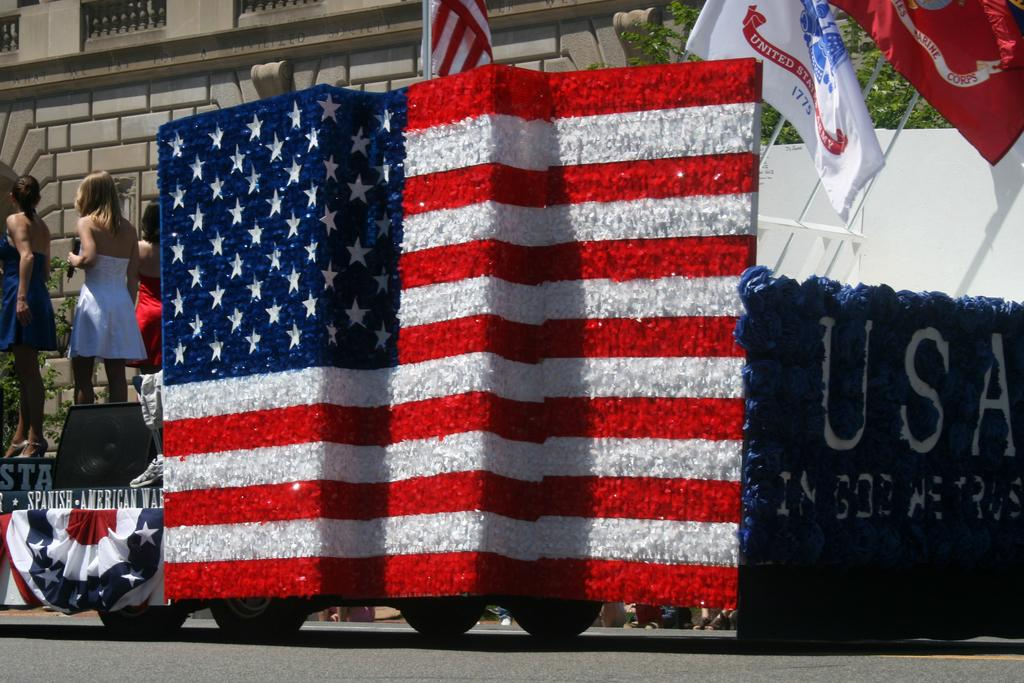Provide a one-sentence caption for the provided image. A parade is taking place in a town with a float with an American flag on the side. 